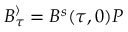<formula> <loc_0><loc_0><loc_500><loc_500>B _ { \tau } ^ { \rangle } = B ^ { s } ( \tau , 0 ) P</formula> 